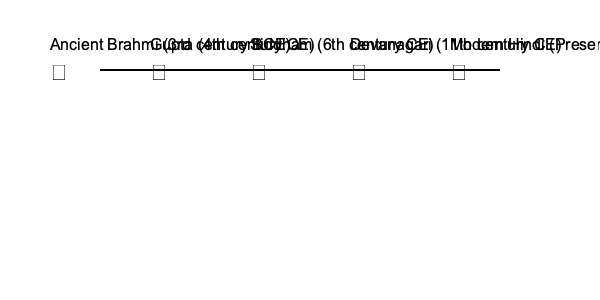Analyze the evolution of the Hindi vowel 'अ' (a) from its Brahmi origins to its modern form. What significant changes occurred during the Gupta and Siddham periods, and how did these transformations contribute to the development of the Devanagari script used in modern Hindi? 1. Brahmi script (3rd century BCE):
   - The vowel 'अ' is represented by a simple vertical line with a slight curve at the top.
   - This form is the foundation for all subsequent developments.

2. Gupta script (4th century CE):
   - The character becomes more ornate, with a pronounced curve at the top.
   - A horizontal line is added at the bottom, introducing the concept of a headline.

3. Siddham script (6th century CE):
   - The curve at the top becomes more exaggerated and elongated.
   - The vertical line becomes slightly slanted, moving towards a more cursive style.

4. Devanagari script (11th century CE):
   - The top curve evolves into a distinct loop.
   - The vertical line becomes straighter again.
   - The bottom horizontal line (headline) becomes more prominent.

5. Modern Hindi:
   - The character retains the basic structure from the Devanagari script.
   - Slight refinements in proportions and stroke thickness for improved legibility in print and digital formats.

Key transformations:
1. Introduction of the headline during the Gupta period, which became a defining feature of the Devanagari script.
2. Development of more cursive and ornate forms during the Siddham period, influencing the aesthetic of the script.
3. Standardization of the loop and vertical line structure in Devanagari, which directly led to the modern Hindi form.

These changes reflect the script's adaptation to different writing materials and cultural influences over time, ultimately contributing to the distinctive appearance and structure of the Devanagari script used in modern Hindi.
Answer: Introduction of headline in Gupta script; cursive evolution in Siddham; standardization of loop and vertical structure in Devanagari. 